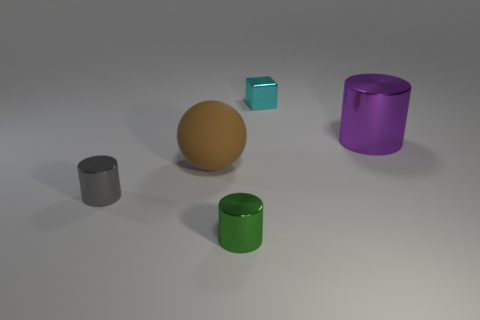Are there any other things that have the same shape as the small cyan thing?
Offer a very short reply. No. The block that is the same size as the gray shiny thing is what color?
Offer a terse response. Cyan. Is there another purple object that has the same material as the big purple object?
Keep it short and to the point. No. Are there fewer green cylinders left of the big metal cylinder than big yellow matte objects?
Offer a very short reply. No. Is the size of the metal object to the left of the brown matte ball the same as the big purple metal object?
Keep it short and to the point. No. What number of other large objects are the same shape as the big metallic object?
Your answer should be compact. 0. What is the size of the purple object that is made of the same material as the green cylinder?
Your answer should be very brief. Large. Are there the same number of green objects that are behind the tiny cyan thing and small purple metal balls?
Ensure brevity in your answer.  Yes. Is the shape of the small metallic thing in front of the small gray metallic object the same as the tiny metallic object that is left of the green metal thing?
Ensure brevity in your answer.  Yes. What material is the small gray object that is the same shape as the big metallic object?
Provide a short and direct response. Metal. 